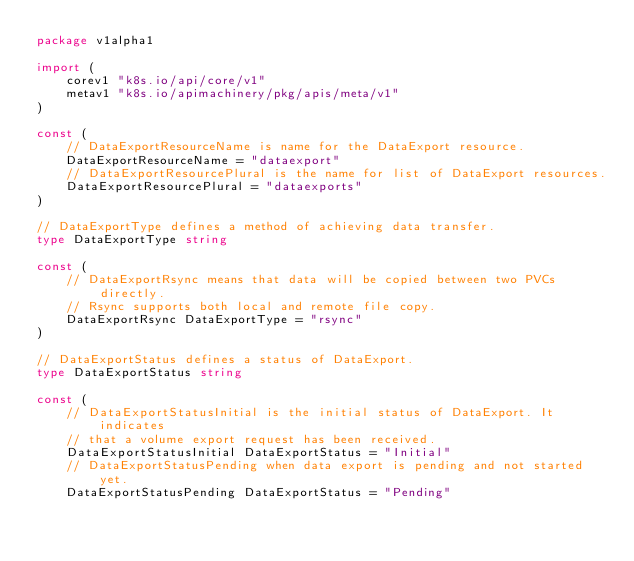Convert code to text. <code><loc_0><loc_0><loc_500><loc_500><_Go_>package v1alpha1

import (
	corev1 "k8s.io/api/core/v1"
	metav1 "k8s.io/apimachinery/pkg/apis/meta/v1"
)

const (
	// DataExportResourceName is name for the DataExport resource.
	DataExportResourceName = "dataexport"
	// DataExportResourcePlural is the name for list of DataExport resources.
	DataExportResourcePlural = "dataexports"
)

// DataExportType defines a method of achieving data transfer.
type DataExportType string

const (
	// DataExportRsync means that data will be copied between two PVCs directly.
	// Rsync supports both local and remote file copy.
	DataExportRsync DataExportType = "rsync"
)

// DataExportStatus defines a status of DataExport.
type DataExportStatus string

const (
	// DataExportStatusInitial is the initial status of DataExport. It indicates
	// that a volume export request has been received.
	DataExportStatusInitial DataExportStatus = "Initial"
	// DataExportStatusPending when data export is pending and not started yet.
	DataExportStatusPending DataExportStatus = "Pending"</code> 